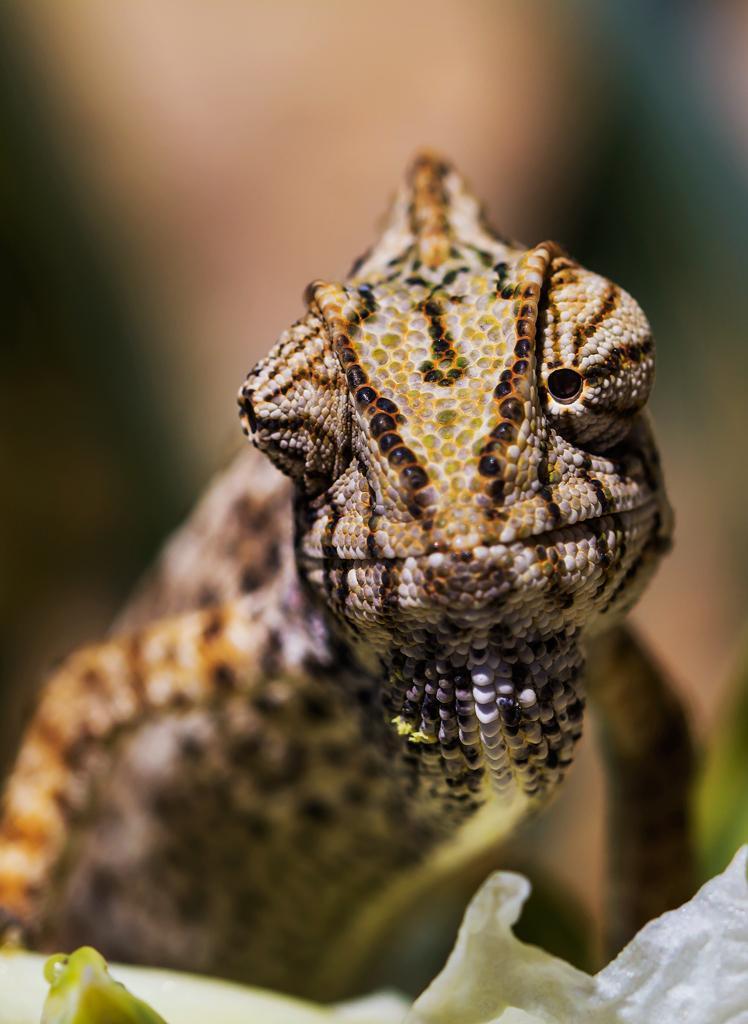In one or two sentences, can you explain what this image depicts? In the middle of this image, there is an animal having opened its one eye. On the right side, there is a white color object. And the background is blurred. 